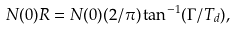<formula> <loc_0><loc_0><loc_500><loc_500>N ( 0 ) R = N ( 0 ) ( 2 / \pi ) \tan ^ { - 1 } ( \Gamma / T _ { d } ) ,</formula> 